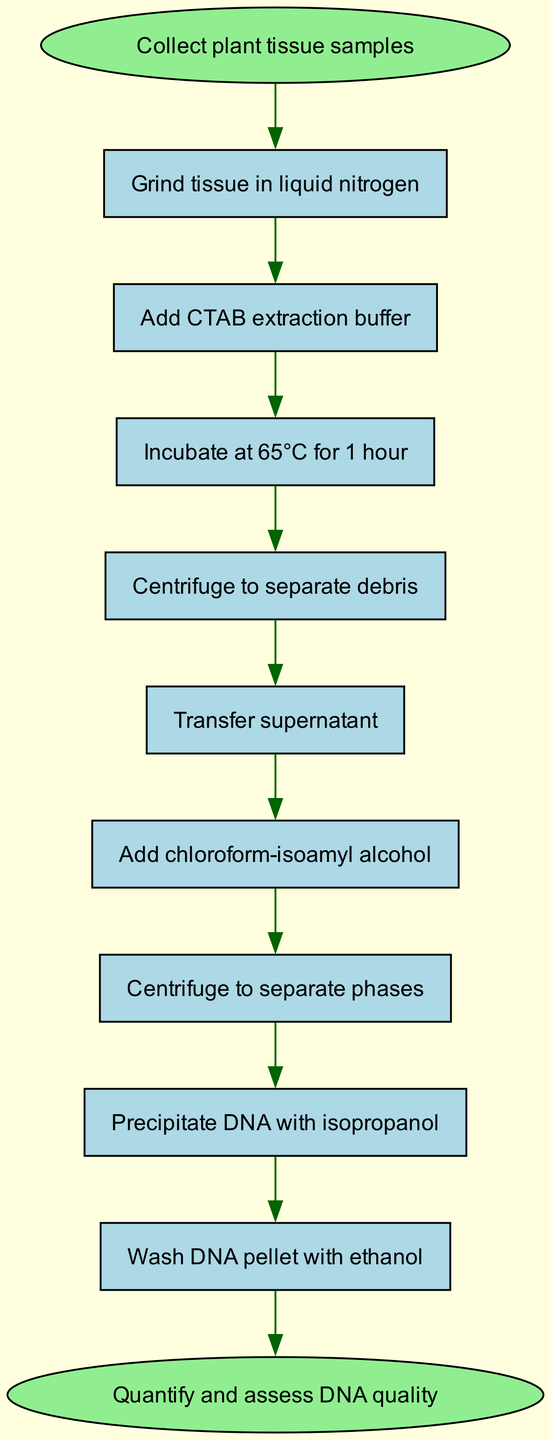What is the initial action in the protocol? The diagram indicates the initial action is represented by the "start" node, which states "Collect plant tissue samples." This is the first step in the sequence of actions.
Answer: Collect plant tissue samples What is the last step before the quantification of DNA? To find this, I look for the node right before the "end" node in the diagram, which is indicated as "Wash DNA pellet with ethanol." It directly leads to the final quantification step.
Answer: Wash DNA pellet with ethanol How many total steps are there in the protocol? Counting the nodes labeled for each action excluding start and end gives 9 actions (steps) in total. Hence, the total number of steps is 9.
Answer: 9 What is the temperature for DNA extraction incubation? In the diagram, the step “Incubate at 65°C for 1 hour” specifies the temperature for the DNA extraction process, clearly stated in that node.
Answer: 65°C Which step follows the action of adding chloroform-isoamyl alcohol? Looking at the flow from the node marked "Add chloroform-isoamyl alcohol," the next step in the sequence indicated by the following node is "Centrifuge to separate phases."
Answer: Centrifuge to separate phases What is the action that comes after the transfer of supernatant? From reviewing the flow of actions in the diagram, after transferring the supernatant, the subsequent step is "Add chloroform-isoamyl alcohol."
Answer: Add chloroform-isoamyl alcohol Which steps involve centrifugation? By analyzing the diagram, there are two instances of centrifugation: "Centrifuge to separate debris" and "Centrifuge to separate phases." These steps both include the action of centrifugation.
Answer: Centrifuge to separate debris, Centrifuge to separate phases What reagent is used to precipitate DNA? In the diagram, the node labeled "Precipitate DNA with isopropanol" identifies the reagent used in this step specifically, which is isopropanol.
Answer: Isopropanol 